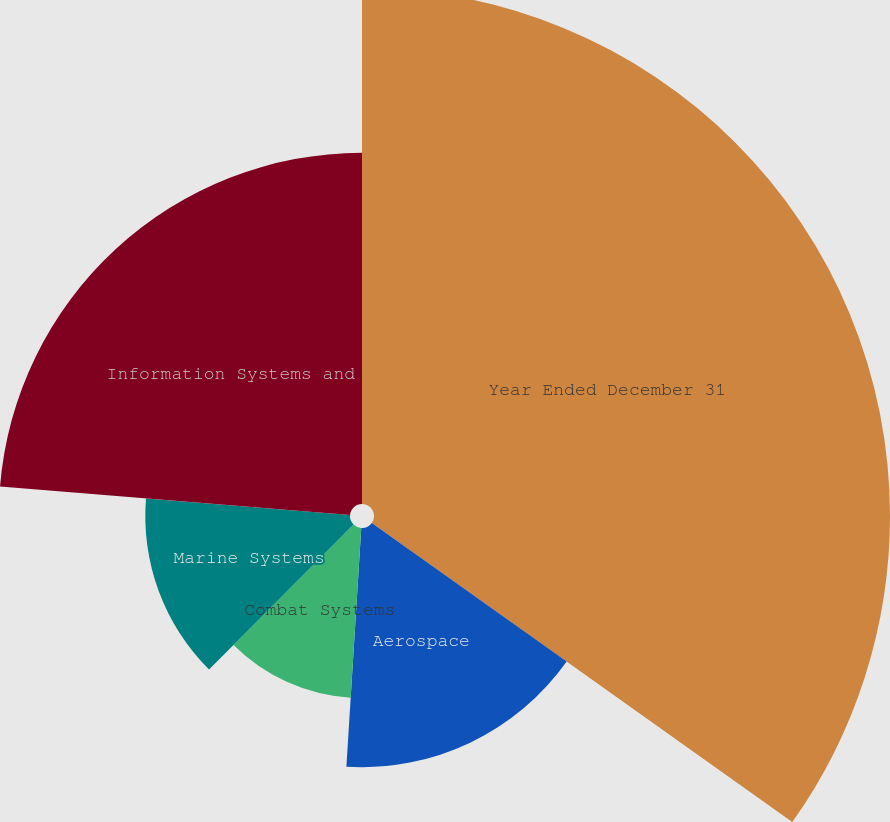<chart> <loc_0><loc_0><loc_500><loc_500><pie_chart><fcel>Year Ended December 31<fcel>Aerospace<fcel>Combat Systems<fcel>Marine Systems<fcel>Information Systems and<nl><fcel>34.84%<fcel>16.15%<fcel>11.48%<fcel>13.82%<fcel>23.71%<nl></chart> 